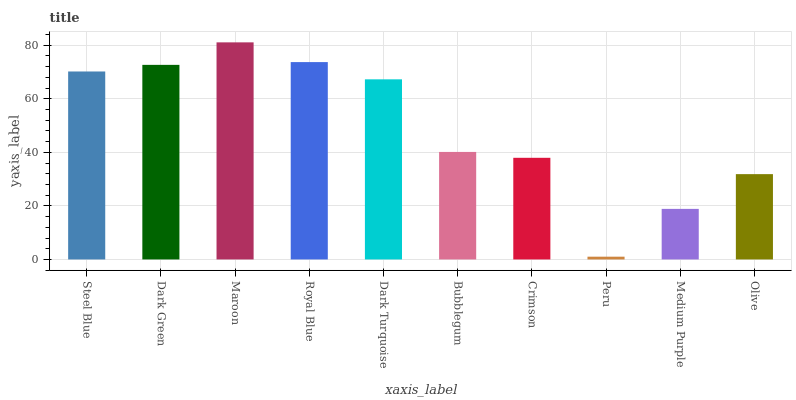Is Peru the minimum?
Answer yes or no. Yes. Is Maroon the maximum?
Answer yes or no. Yes. Is Dark Green the minimum?
Answer yes or no. No. Is Dark Green the maximum?
Answer yes or no. No. Is Dark Green greater than Steel Blue?
Answer yes or no. Yes. Is Steel Blue less than Dark Green?
Answer yes or no. Yes. Is Steel Blue greater than Dark Green?
Answer yes or no. No. Is Dark Green less than Steel Blue?
Answer yes or no. No. Is Dark Turquoise the high median?
Answer yes or no. Yes. Is Bubblegum the low median?
Answer yes or no. Yes. Is Royal Blue the high median?
Answer yes or no. No. Is Crimson the low median?
Answer yes or no. No. 